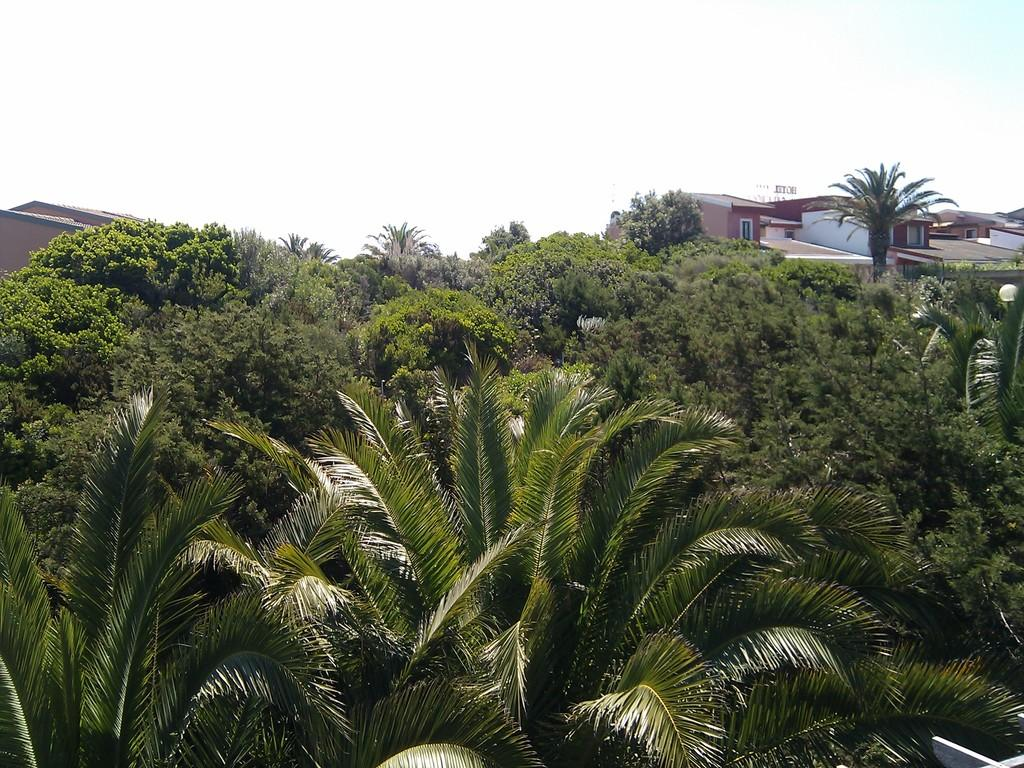What type of natural elements can be seen in the image? There are trees in the image. What type of illumination is present in the image? There is light in the image. What type of man-made structures can be seen in the background of the image? There are buildings in the background of the image. What part of the natural environment is visible in the background of the image? The sky is visible in the background of the image. What type of paper is being used to make the sail in the image? There is no sail present in the image, so it is not possible to determine what type of paper might be used. 